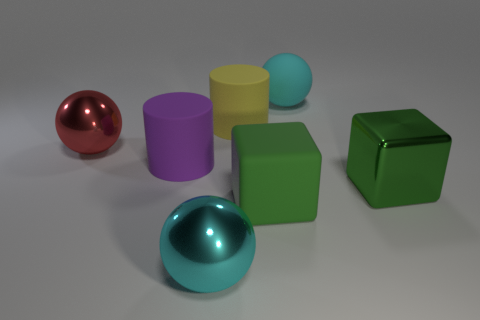Add 2 big cyan objects. How many objects exist? 9 Subtract all spheres. How many objects are left? 4 Add 4 matte objects. How many matte objects are left? 8 Add 2 big things. How many big things exist? 9 Subtract 1 yellow cylinders. How many objects are left? 6 Subtract all big matte objects. Subtract all matte cylinders. How many objects are left? 1 